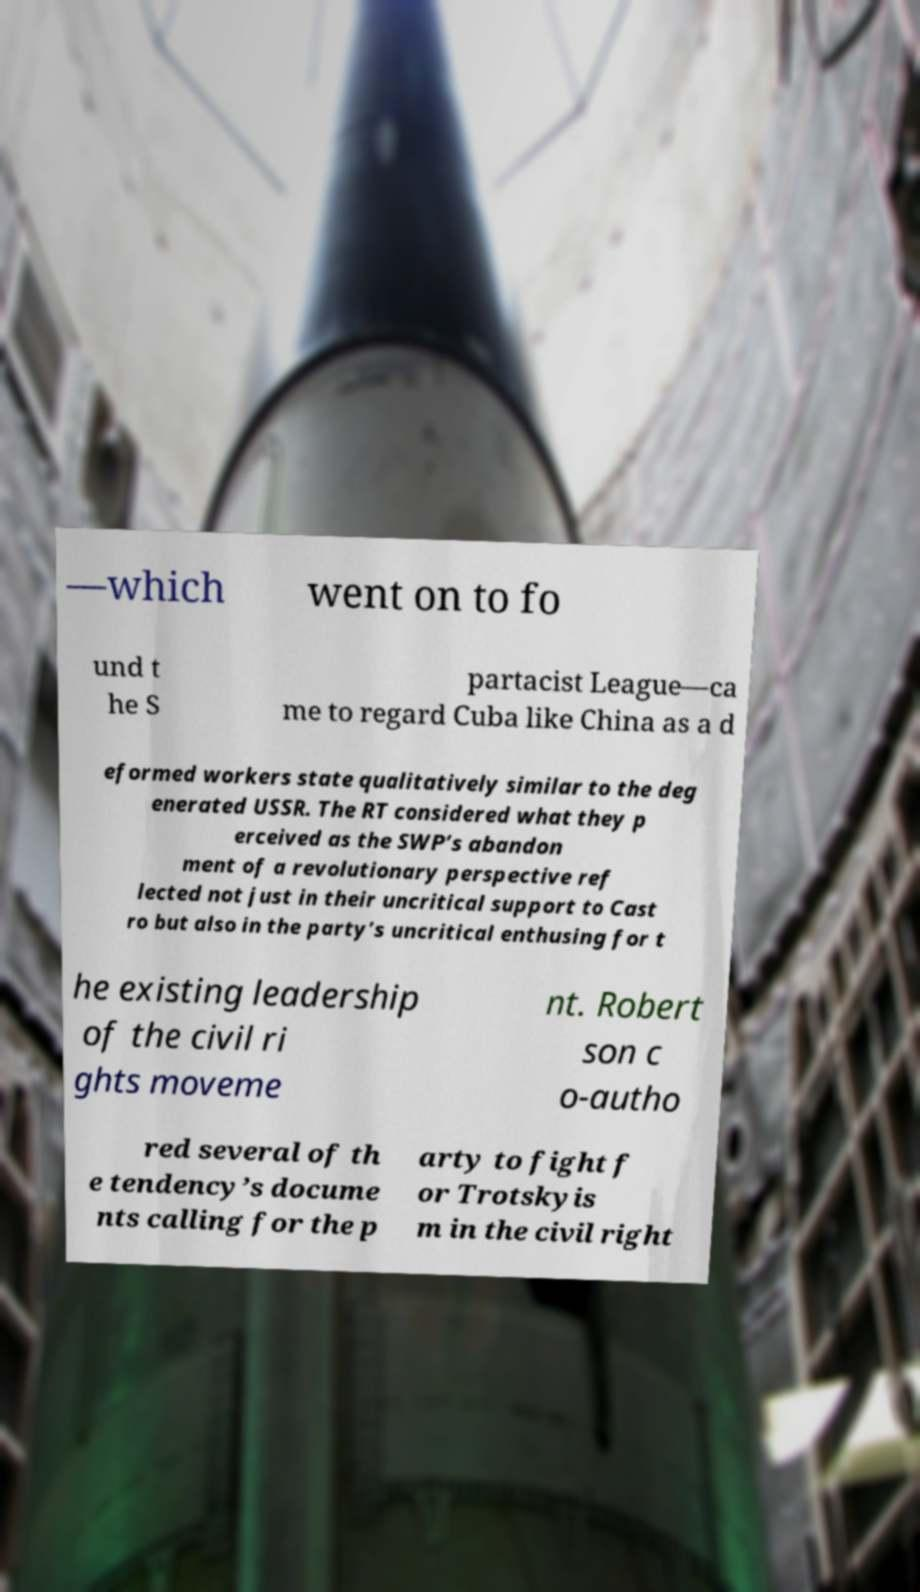Could you assist in decoding the text presented in this image and type it out clearly? —which went on to fo und t he S partacist League—ca me to regard Cuba like China as a d eformed workers state qualitatively similar to the deg enerated USSR. The RT considered what they p erceived as the SWP’s abandon ment of a revolutionary perspective ref lected not just in their uncritical support to Cast ro but also in the party’s uncritical enthusing for t he existing leadership of the civil ri ghts moveme nt. Robert son c o-autho red several of th e tendency’s docume nts calling for the p arty to fight f or Trotskyis m in the civil right 